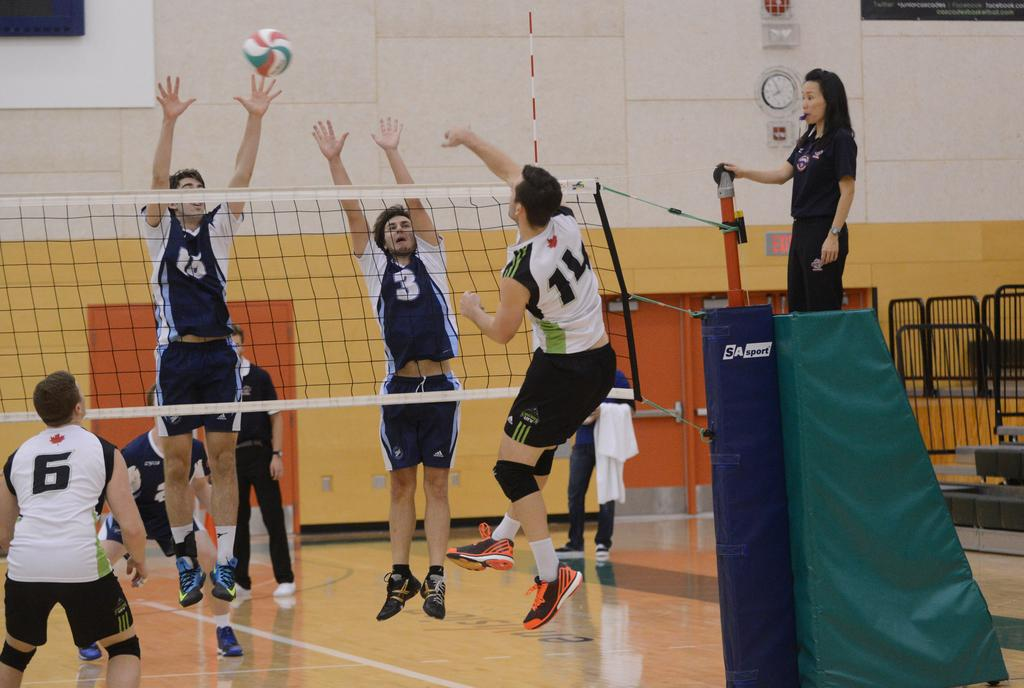What type of structure can be seen in the image? There is a wall in the image. What object is used for measuring time in the image? There is a clock in the image. What object is round and can be used for playing games in the image? There is a ball in the image. What is used to separate areas in the image? There is a net in the image. What type of barrier is present in the image? There is a fence in the image. Are there any people visible in the image? Yes, there are people present in the image. What type of selection process is taking place in the image? There is no selection process visible in the image. What type of board is being used by the people in the image? There is no board present in the image. What type of badge is being worn by the people in the image? There is no badge visible on the people in the image. 